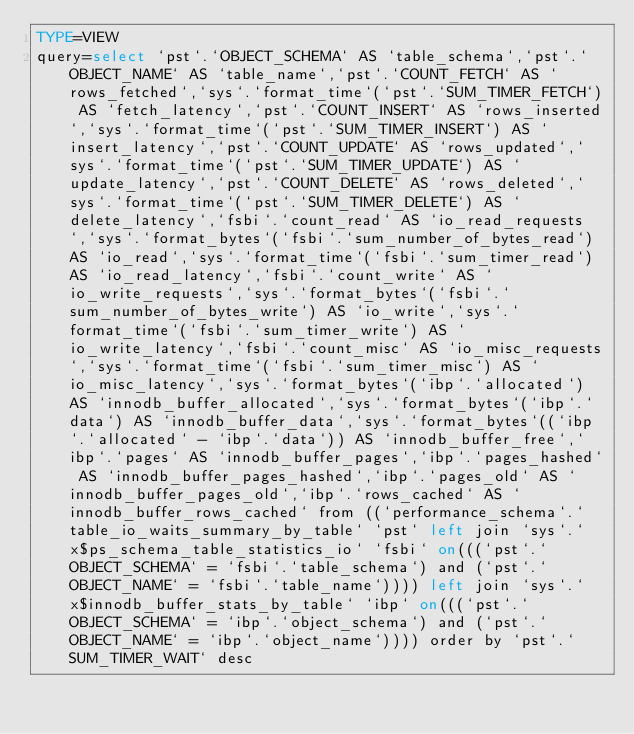Convert code to text. <code><loc_0><loc_0><loc_500><loc_500><_VisualBasic_>TYPE=VIEW
query=select `pst`.`OBJECT_SCHEMA` AS `table_schema`,`pst`.`OBJECT_NAME` AS `table_name`,`pst`.`COUNT_FETCH` AS `rows_fetched`,`sys`.`format_time`(`pst`.`SUM_TIMER_FETCH`) AS `fetch_latency`,`pst`.`COUNT_INSERT` AS `rows_inserted`,`sys`.`format_time`(`pst`.`SUM_TIMER_INSERT`) AS `insert_latency`,`pst`.`COUNT_UPDATE` AS `rows_updated`,`sys`.`format_time`(`pst`.`SUM_TIMER_UPDATE`) AS `update_latency`,`pst`.`COUNT_DELETE` AS `rows_deleted`,`sys`.`format_time`(`pst`.`SUM_TIMER_DELETE`) AS `delete_latency`,`fsbi`.`count_read` AS `io_read_requests`,`sys`.`format_bytes`(`fsbi`.`sum_number_of_bytes_read`) AS `io_read`,`sys`.`format_time`(`fsbi`.`sum_timer_read`) AS `io_read_latency`,`fsbi`.`count_write` AS `io_write_requests`,`sys`.`format_bytes`(`fsbi`.`sum_number_of_bytes_write`) AS `io_write`,`sys`.`format_time`(`fsbi`.`sum_timer_write`) AS `io_write_latency`,`fsbi`.`count_misc` AS `io_misc_requests`,`sys`.`format_time`(`fsbi`.`sum_timer_misc`) AS `io_misc_latency`,`sys`.`format_bytes`(`ibp`.`allocated`) AS `innodb_buffer_allocated`,`sys`.`format_bytes`(`ibp`.`data`) AS `innodb_buffer_data`,`sys`.`format_bytes`((`ibp`.`allocated` - `ibp`.`data`)) AS `innodb_buffer_free`,`ibp`.`pages` AS `innodb_buffer_pages`,`ibp`.`pages_hashed` AS `innodb_buffer_pages_hashed`,`ibp`.`pages_old` AS `innodb_buffer_pages_old`,`ibp`.`rows_cached` AS `innodb_buffer_rows_cached` from ((`performance_schema`.`table_io_waits_summary_by_table` `pst` left join `sys`.`x$ps_schema_table_statistics_io` `fsbi` on(((`pst`.`OBJECT_SCHEMA` = `fsbi`.`table_schema`) and (`pst`.`OBJECT_NAME` = `fsbi`.`table_name`)))) left join `sys`.`x$innodb_buffer_stats_by_table` `ibp` on(((`pst`.`OBJECT_SCHEMA` = `ibp`.`object_schema`) and (`pst`.`OBJECT_NAME` = `ibp`.`object_name`)))) order by `pst`.`SUM_TIMER_WAIT` desc</code> 